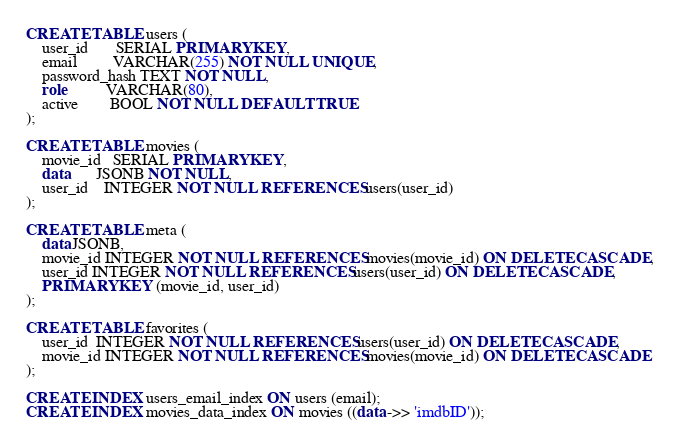<code> <loc_0><loc_0><loc_500><loc_500><_SQL_>CREATE TABLE users (
    user_id       SERIAL PRIMARY KEY,
    email         VARCHAR(255) NOT NULL UNIQUE,
    password_hash TEXT NOT NULL,
    role          VARCHAR(80),
    active        BOOL NOT NULL DEFAULT TRUE
);

CREATE TABLE movies (
    movie_id   SERIAL PRIMARY KEY,
    data       JSONB NOT NULL,
    user_id    INTEGER NOT NULL REFERENCES users(user_id)
);

CREATE TABLE meta (
    data JSONB,
    movie_id INTEGER NOT NULL REFERENCES movies(movie_id) ON DELETE CASCADE,
    user_id INTEGER NOT NULL REFERENCES users(user_id) ON DELETE CASCADE,
    PRIMARY KEY (movie_id, user_id)
);

CREATE TABLE favorites (
    user_id  INTEGER NOT NULL REFERENCES users(user_id) ON DELETE CASCADE,
    movie_id INTEGER NOT NULL REFERENCES movies(movie_id) ON DELETE CASCADE
);

CREATE INDEX users_email_index ON users (email);
CREATE INDEX movies_data_index ON movies ((data ->> 'imdbID'));
</code> 